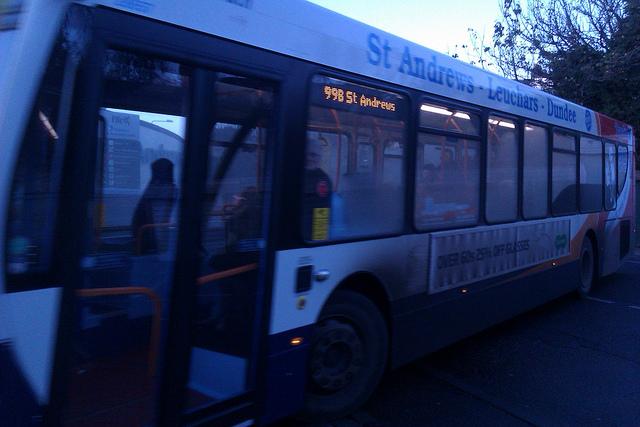How many decks does the bus in the front have?
Answer briefly. 1. Where is the bus traveling to?
Give a very brief answer. St andrews. Is this the front or back of the bus?
Answer briefly. Front. How many windows are on the bus?
Concise answer only. 16. Is this a public bus?
Answer briefly. Yes. Is this daytime?
Be succinct. No. Where won't this bus take you?
Quick response, please. Home. Is it sunny?
Be succinct. No. 